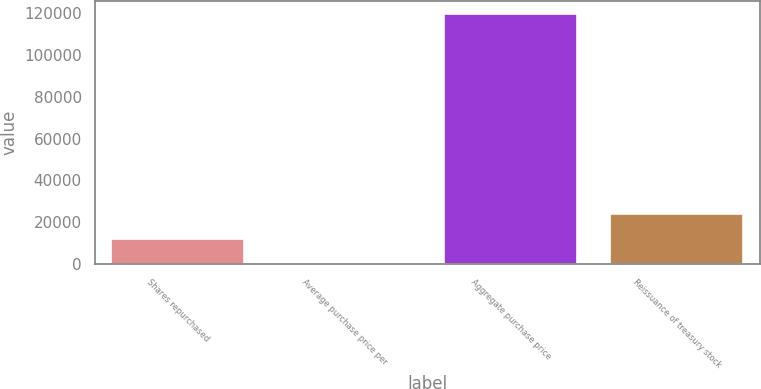Convert chart. <chart><loc_0><loc_0><loc_500><loc_500><bar_chart><fcel>Shares repurchased<fcel>Average purchase price per<fcel>Aggregate purchase price<fcel>Reissuance of treasury stock<nl><fcel>12009.5<fcel>38.72<fcel>119747<fcel>23980.4<nl></chart> 